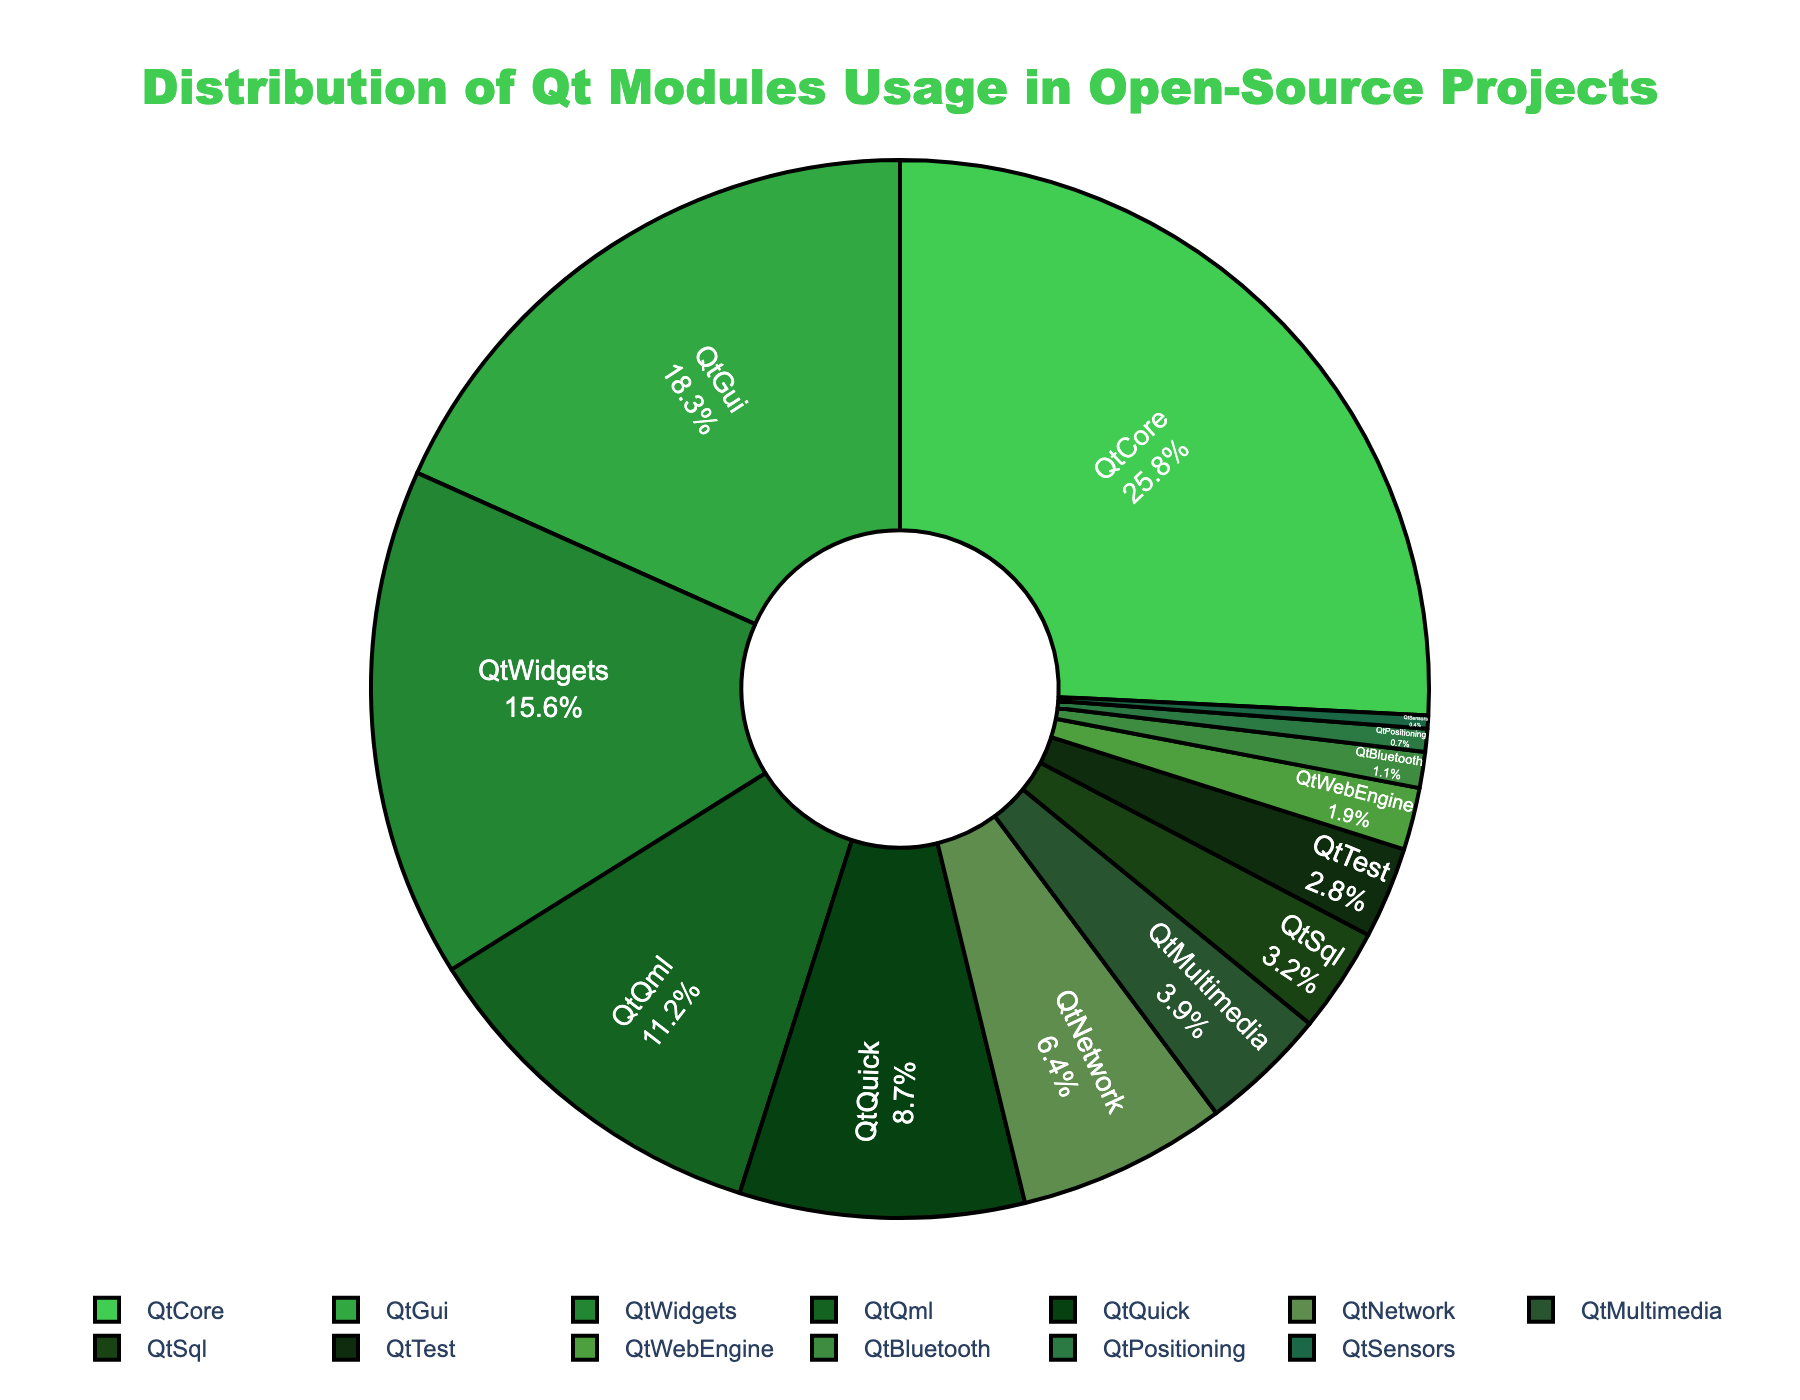What is the most used Qt module? The pie chart shows the percentages of usage for each Qt module. The QtCore module has the highest percentage at 25.8%, making it the most used module.
Answer: QtCore Which two modules have the closest usage percentages? Looking at the usage percentages, QtSql (3.2%) and QtTest (2.8%) have close values with a difference of just 0.4 percentage points between them.
Answer: QtSql and QtTest How much more is QtCore used compared to QtQml? QtCore has a usage of 25.8%, and QtQml has a usage of 11.2%. Subtracting these gives the difference: 25.8 - 11.2 = 14.6.
Answer: 14.6% Which modules each hold less than 2% of the total usage? The modules with usage percentages less than 2% are QtWebEngine (1.9%), QtBluetooth (1.1%), QtPositioning (0.7%), and QtSensors (0.4%).
Answer: QtWebEngine, QtBluetooth, QtPositioning, and QtSensors Combined, what percentage of the usage do the three least-used modules constitute? The three least-used modules are QtPositioning (0.7%), QtSensors (0.4%), and QtBluetooth (1.1%). Adding these together: 0.7 + 0.4 + 1.1 = 2.2%.
Answer: 2.2% How many modules have a usage percentage greater than 5%? Looking at the chart, the modules with usage percentages greater than 5% are QtCore, QtGui, QtWidgets, QtQml, QtQuick, and QtNetwork.
Answer: 6 modules Which module uses a green color that is darker than the color used for QtGui but lighter than the color used for QtMultimedia? By visually comparing the shades of green, it's clear that the color for QtWidgets (darker than QtGui but lighter than QtMultimedia) fits this description.
Answer: QtWidgets If the usage of QtQuick increased by 5%, what would its new usage percentage be and how would it compare to QtWidgets? QtQuick's current usage is 8.7%. If it increased by 5%, the new usage would be 8.7 + 5 = 13.7%. Comparing to QtWidgets at 15.6%, QtWidgets would still be more used by 1.9%.
Answer: 13.7%, QtWidgets is more used by 1.9% What percentage of the total usage is accumulated by the top four most-used modules? The top four most-used modules are QtCore, QtGui, QtWidgets, and QtQml. Adding their percentages: 25.8 + 18.3 + 15.6 + 11.2 = 70.9%.
Answer: 70.9% Which module is more popular, QtWebEngine or QtTest, and by how much? QtTest has a usage percentage of 2.8%, while QtWebEngine is at 1.9%. Subtracting these gives the difference: 2.8 - 1.9 = 0.9%. Therefore, QtTest is more popular by 0.9%.
Answer: QtTest, by 0.9% 